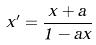<formula> <loc_0><loc_0><loc_500><loc_500>x ^ { \prime } = \frac { x + a } { 1 - a x }</formula> 